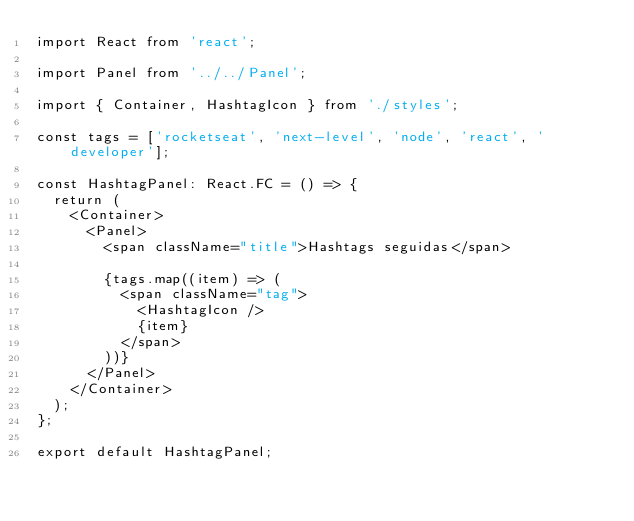<code> <loc_0><loc_0><loc_500><loc_500><_TypeScript_>import React from 'react';

import Panel from '../../Panel';

import { Container, HashtagIcon } from './styles';

const tags = ['rocketseat', 'next-level', 'node', 'react', 'developer'];

const HashtagPanel: React.FC = () => {
  return (
    <Container>
      <Panel>
        <span className="title">Hashtags seguidas</span>

        {tags.map((item) => (
          <span className="tag">
            <HashtagIcon />
            {item}
          </span>
        ))}
      </Panel>
    </Container>
  );
};

export default HashtagPanel;
</code> 